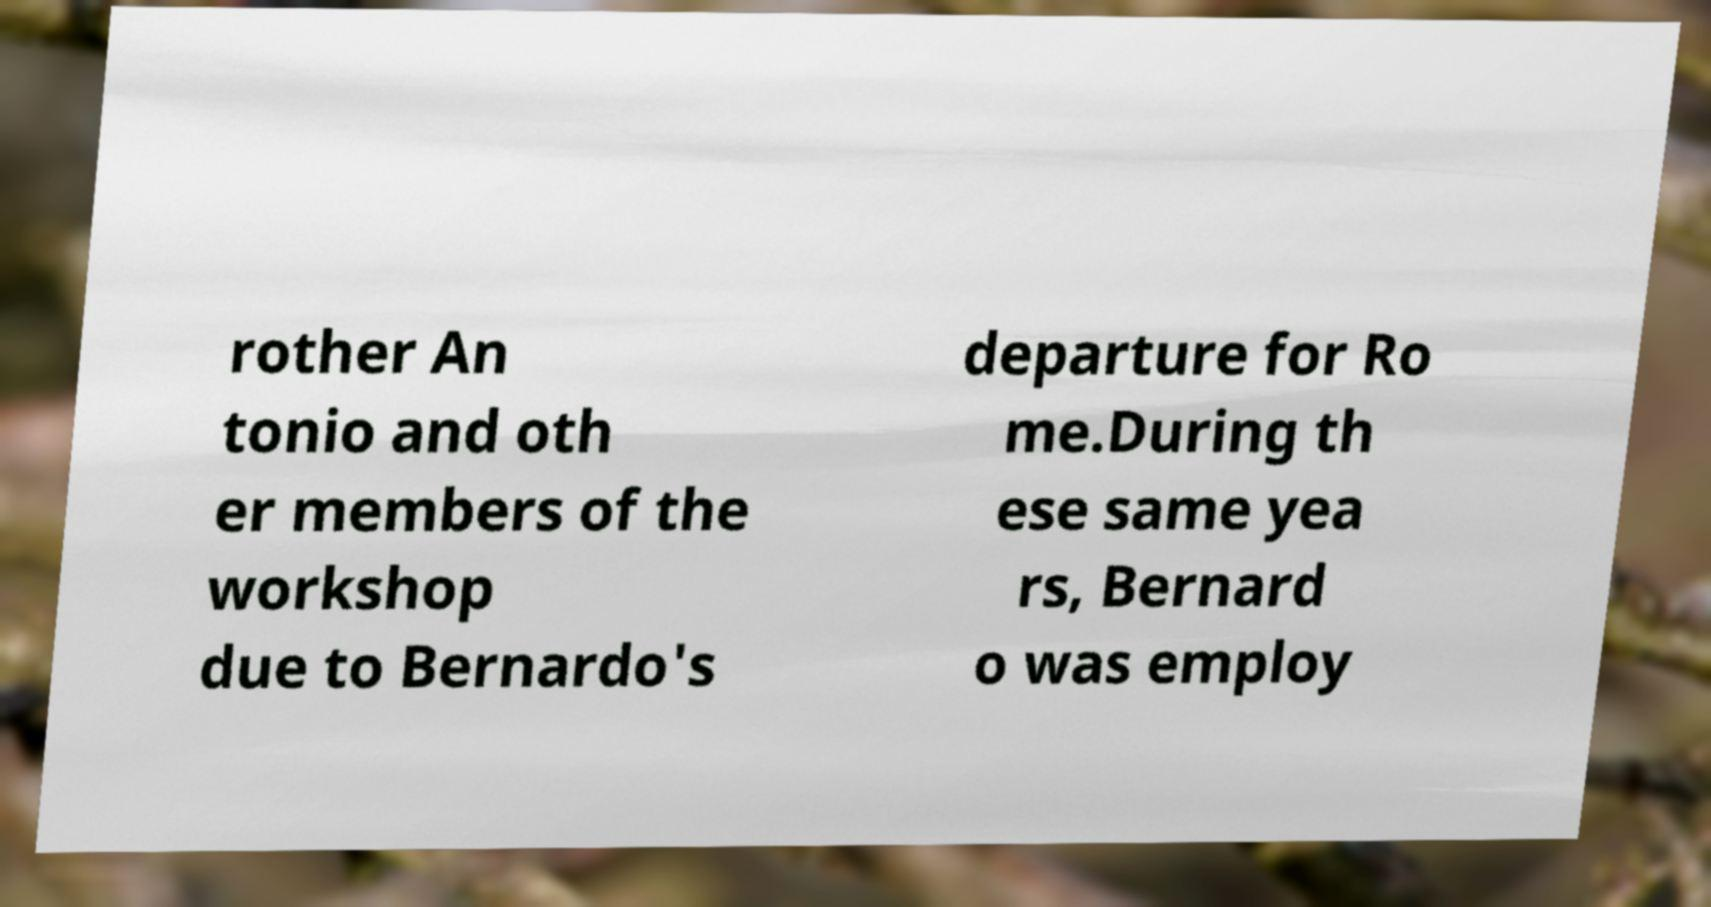Please identify and transcribe the text found in this image. rother An tonio and oth er members of the workshop due to Bernardo's departure for Ro me.During th ese same yea rs, Bernard o was employ 